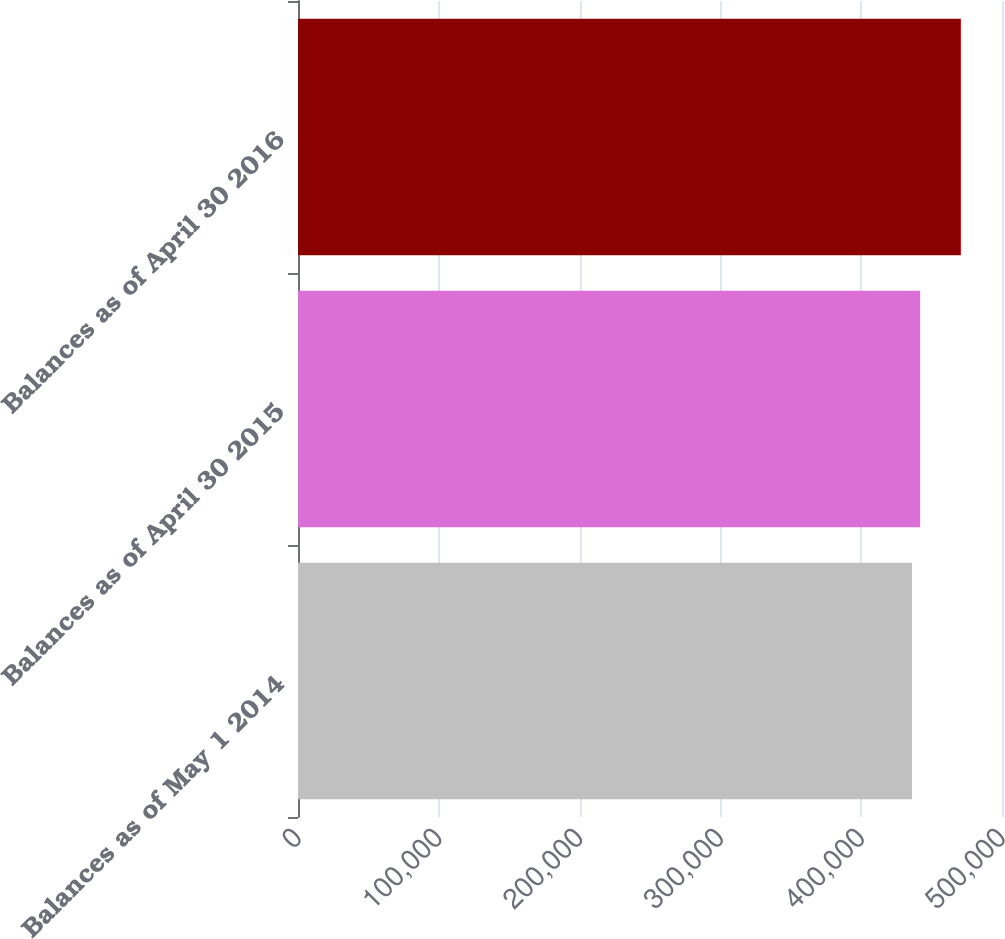Convert chart. <chart><loc_0><loc_0><loc_500><loc_500><bar_chart><fcel>Balances as of May 1 2014<fcel>Balances as of April 30 2015<fcel>Balances as of April 30 2016<nl><fcel>436117<fcel>441831<fcel>470757<nl></chart> 